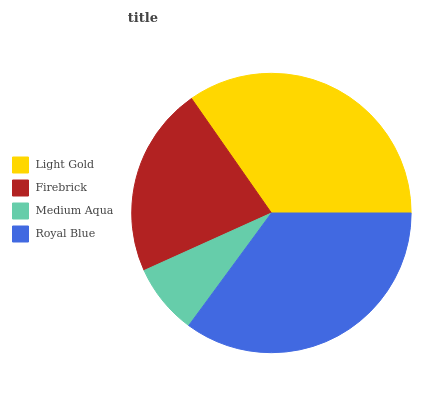Is Medium Aqua the minimum?
Answer yes or no. Yes. Is Royal Blue the maximum?
Answer yes or no. Yes. Is Firebrick the minimum?
Answer yes or no. No. Is Firebrick the maximum?
Answer yes or no. No. Is Light Gold greater than Firebrick?
Answer yes or no. Yes. Is Firebrick less than Light Gold?
Answer yes or no. Yes. Is Firebrick greater than Light Gold?
Answer yes or no. No. Is Light Gold less than Firebrick?
Answer yes or no. No. Is Light Gold the high median?
Answer yes or no. Yes. Is Firebrick the low median?
Answer yes or no. Yes. Is Firebrick the high median?
Answer yes or no. No. Is Royal Blue the low median?
Answer yes or no. No. 